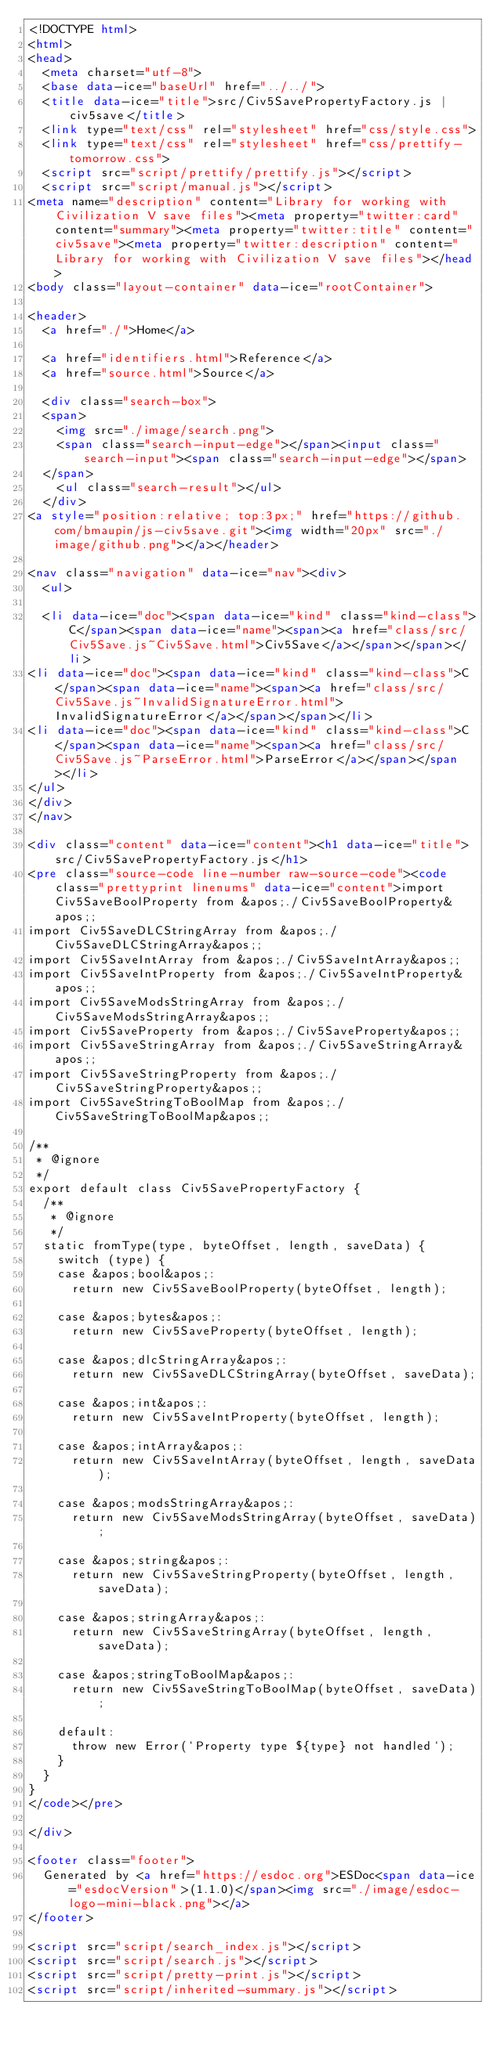<code> <loc_0><loc_0><loc_500><loc_500><_HTML_><!DOCTYPE html>
<html>
<head>
  <meta charset="utf-8">
  <base data-ice="baseUrl" href="../../">
  <title data-ice="title">src/Civ5SavePropertyFactory.js | civ5save</title>
  <link type="text/css" rel="stylesheet" href="css/style.css">
  <link type="text/css" rel="stylesheet" href="css/prettify-tomorrow.css">
  <script src="script/prettify/prettify.js"></script>
  <script src="script/manual.js"></script>
<meta name="description" content="Library for working with Civilization V save files"><meta property="twitter:card" content="summary"><meta property="twitter:title" content="civ5save"><meta property="twitter:description" content="Library for working with Civilization V save files"></head>
<body class="layout-container" data-ice="rootContainer">

<header>
  <a href="./">Home</a>
  
  <a href="identifiers.html">Reference</a>
  <a href="source.html">Source</a>
  
  <div class="search-box">
  <span>
    <img src="./image/search.png">
    <span class="search-input-edge"></span><input class="search-input"><span class="search-input-edge"></span>
  </span>
    <ul class="search-result"></ul>
  </div>
<a style="position:relative; top:3px;" href="https://github.com/bmaupin/js-civ5save.git"><img width="20px" src="./image/github.png"></a></header>

<nav class="navigation" data-ice="nav"><div>
  <ul>
    
  <li data-ice="doc"><span data-ice="kind" class="kind-class">C</span><span data-ice="name"><span><a href="class/src/Civ5Save.js~Civ5Save.html">Civ5Save</a></span></span></li>
<li data-ice="doc"><span data-ice="kind" class="kind-class">C</span><span data-ice="name"><span><a href="class/src/Civ5Save.js~InvalidSignatureError.html">InvalidSignatureError</a></span></span></li>
<li data-ice="doc"><span data-ice="kind" class="kind-class">C</span><span data-ice="name"><span><a href="class/src/Civ5Save.js~ParseError.html">ParseError</a></span></span></li>
</ul>
</div>
</nav>

<div class="content" data-ice="content"><h1 data-ice="title">src/Civ5SavePropertyFactory.js</h1>
<pre class="source-code line-number raw-source-code"><code class="prettyprint linenums" data-ice="content">import Civ5SaveBoolProperty from &apos;./Civ5SaveBoolProperty&apos;;
import Civ5SaveDLCStringArray from &apos;./Civ5SaveDLCStringArray&apos;;
import Civ5SaveIntArray from &apos;./Civ5SaveIntArray&apos;;
import Civ5SaveIntProperty from &apos;./Civ5SaveIntProperty&apos;;
import Civ5SaveModsStringArray from &apos;./Civ5SaveModsStringArray&apos;;
import Civ5SaveProperty from &apos;./Civ5SaveProperty&apos;;
import Civ5SaveStringArray from &apos;./Civ5SaveStringArray&apos;;
import Civ5SaveStringProperty from &apos;./Civ5SaveStringProperty&apos;;
import Civ5SaveStringToBoolMap from &apos;./Civ5SaveStringToBoolMap&apos;;

/**
 * @ignore
 */
export default class Civ5SavePropertyFactory {
  /**
   * @ignore
   */
  static fromType(type, byteOffset, length, saveData) {
    switch (type) {
    case &apos;bool&apos;:
      return new Civ5SaveBoolProperty(byteOffset, length);

    case &apos;bytes&apos;:
      return new Civ5SaveProperty(byteOffset, length);

    case &apos;dlcStringArray&apos;:
      return new Civ5SaveDLCStringArray(byteOffset, saveData);

    case &apos;int&apos;:
      return new Civ5SaveIntProperty(byteOffset, length);

    case &apos;intArray&apos;:
      return new Civ5SaveIntArray(byteOffset, length, saveData);

    case &apos;modsStringArray&apos;:
      return new Civ5SaveModsStringArray(byteOffset, saveData);

    case &apos;string&apos;:
      return new Civ5SaveStringProperty(byteOffset, length, saveData);

    case &apos;stringArray&apos;:
      return new Civ5SaveStringArray(byteOffset, length, saveData);

    case &apos;stringToBoolMap&apos;:
      return new Civ5SaveStringToBoolMap(byteOffset, saveData);

    default:
      throw new Error(`Property type ${type} not handled`);
    }
  }
}
</code></pre>

</div>

<footer class="footer">
  Generated by <a href="https://esdoc.org">ESDoc<span data-ice="esdocVersion">(1.1.0)</span><img src="./image/esdoc-logo-mini-black.png"></a>
</footer>

<script src="script/search_index.js"></script>
<script src="script/search.js"></script>
<script src="script/pretty-print.js"></script>
<script src="script/inherited-summary.js"></script></code> 